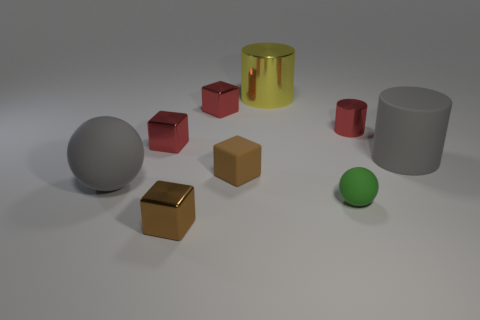What color is the tiny cylinder that is the same material as the big yellow object?
Make the answer very short. Red. There is a gray thing to the left of the large thing that is behind the big gray rubber cylinder; how many green rubber spheres are behind it?
Keep it short and to the point. 0. There is a big cylinder that is the same color as the large sphere; what is it made of?
Your answer should be very brief. Rubber. Is there anything else that is the same shape as the tiny brown metal thing?
Give a very brief answer. Yes. What number of things are either small metallic things in front of the gray rubber sphere or yellow matte cylinders?
Offer a very short reply. 1. Is the color of the large rubber sphere on the left side of the small brown metallic thing the same as the small ball?
Keep it short and to the point. No. The large gray thing in front of the tiny matte thing that is to the left of the large shiny cylinder is what shape?
Ensure brevity in your answer.  Sphere. Is the number of tiny green matte things that are on the right side of the green rubber sphere less than the number of large gray things that are left of the large gray sphere?
Give a very brief answer. No. There is a gray matte thing that is the same shape as the large yellow object; what is its size?
Your answer should be compact. Large. Is there anything else that is the same size as the yellow metal object?
Your answer should be compact. Yes. 